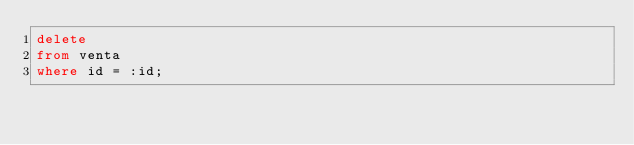Convert code to text. <code><loc_0><loc_0><loc_500><loc_500><_SQL_>delete
from venta
where id = :id;
</code> 